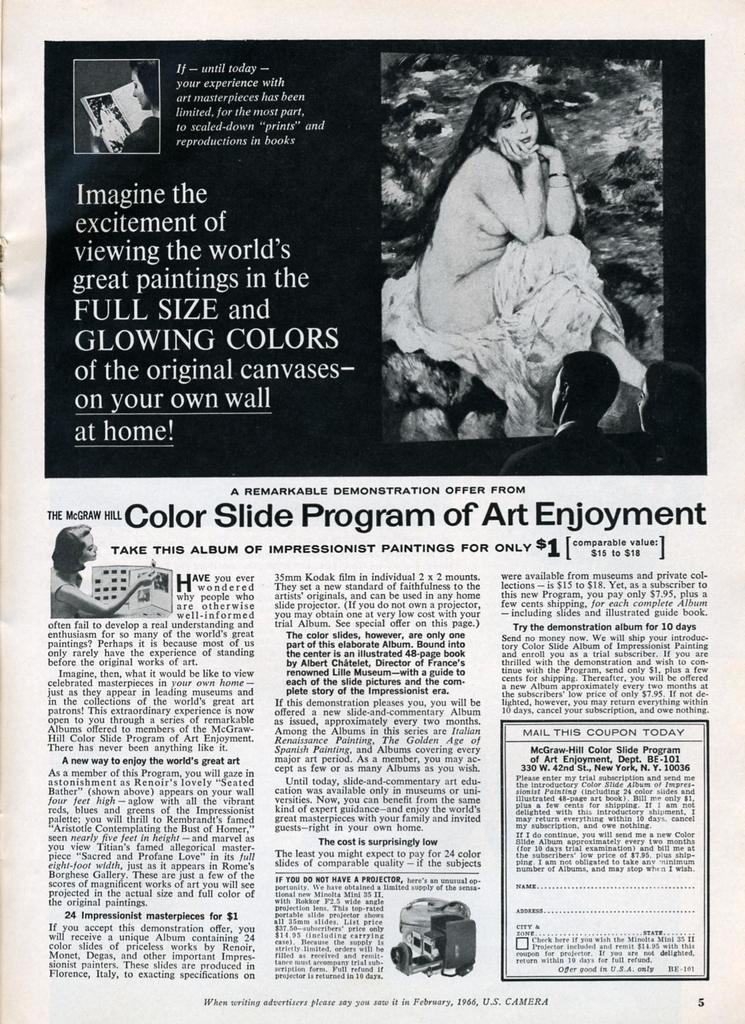Please provide a concise description of this image. In this image, we can see a magazine paper. Here we can see some photographs, painting and some text. 